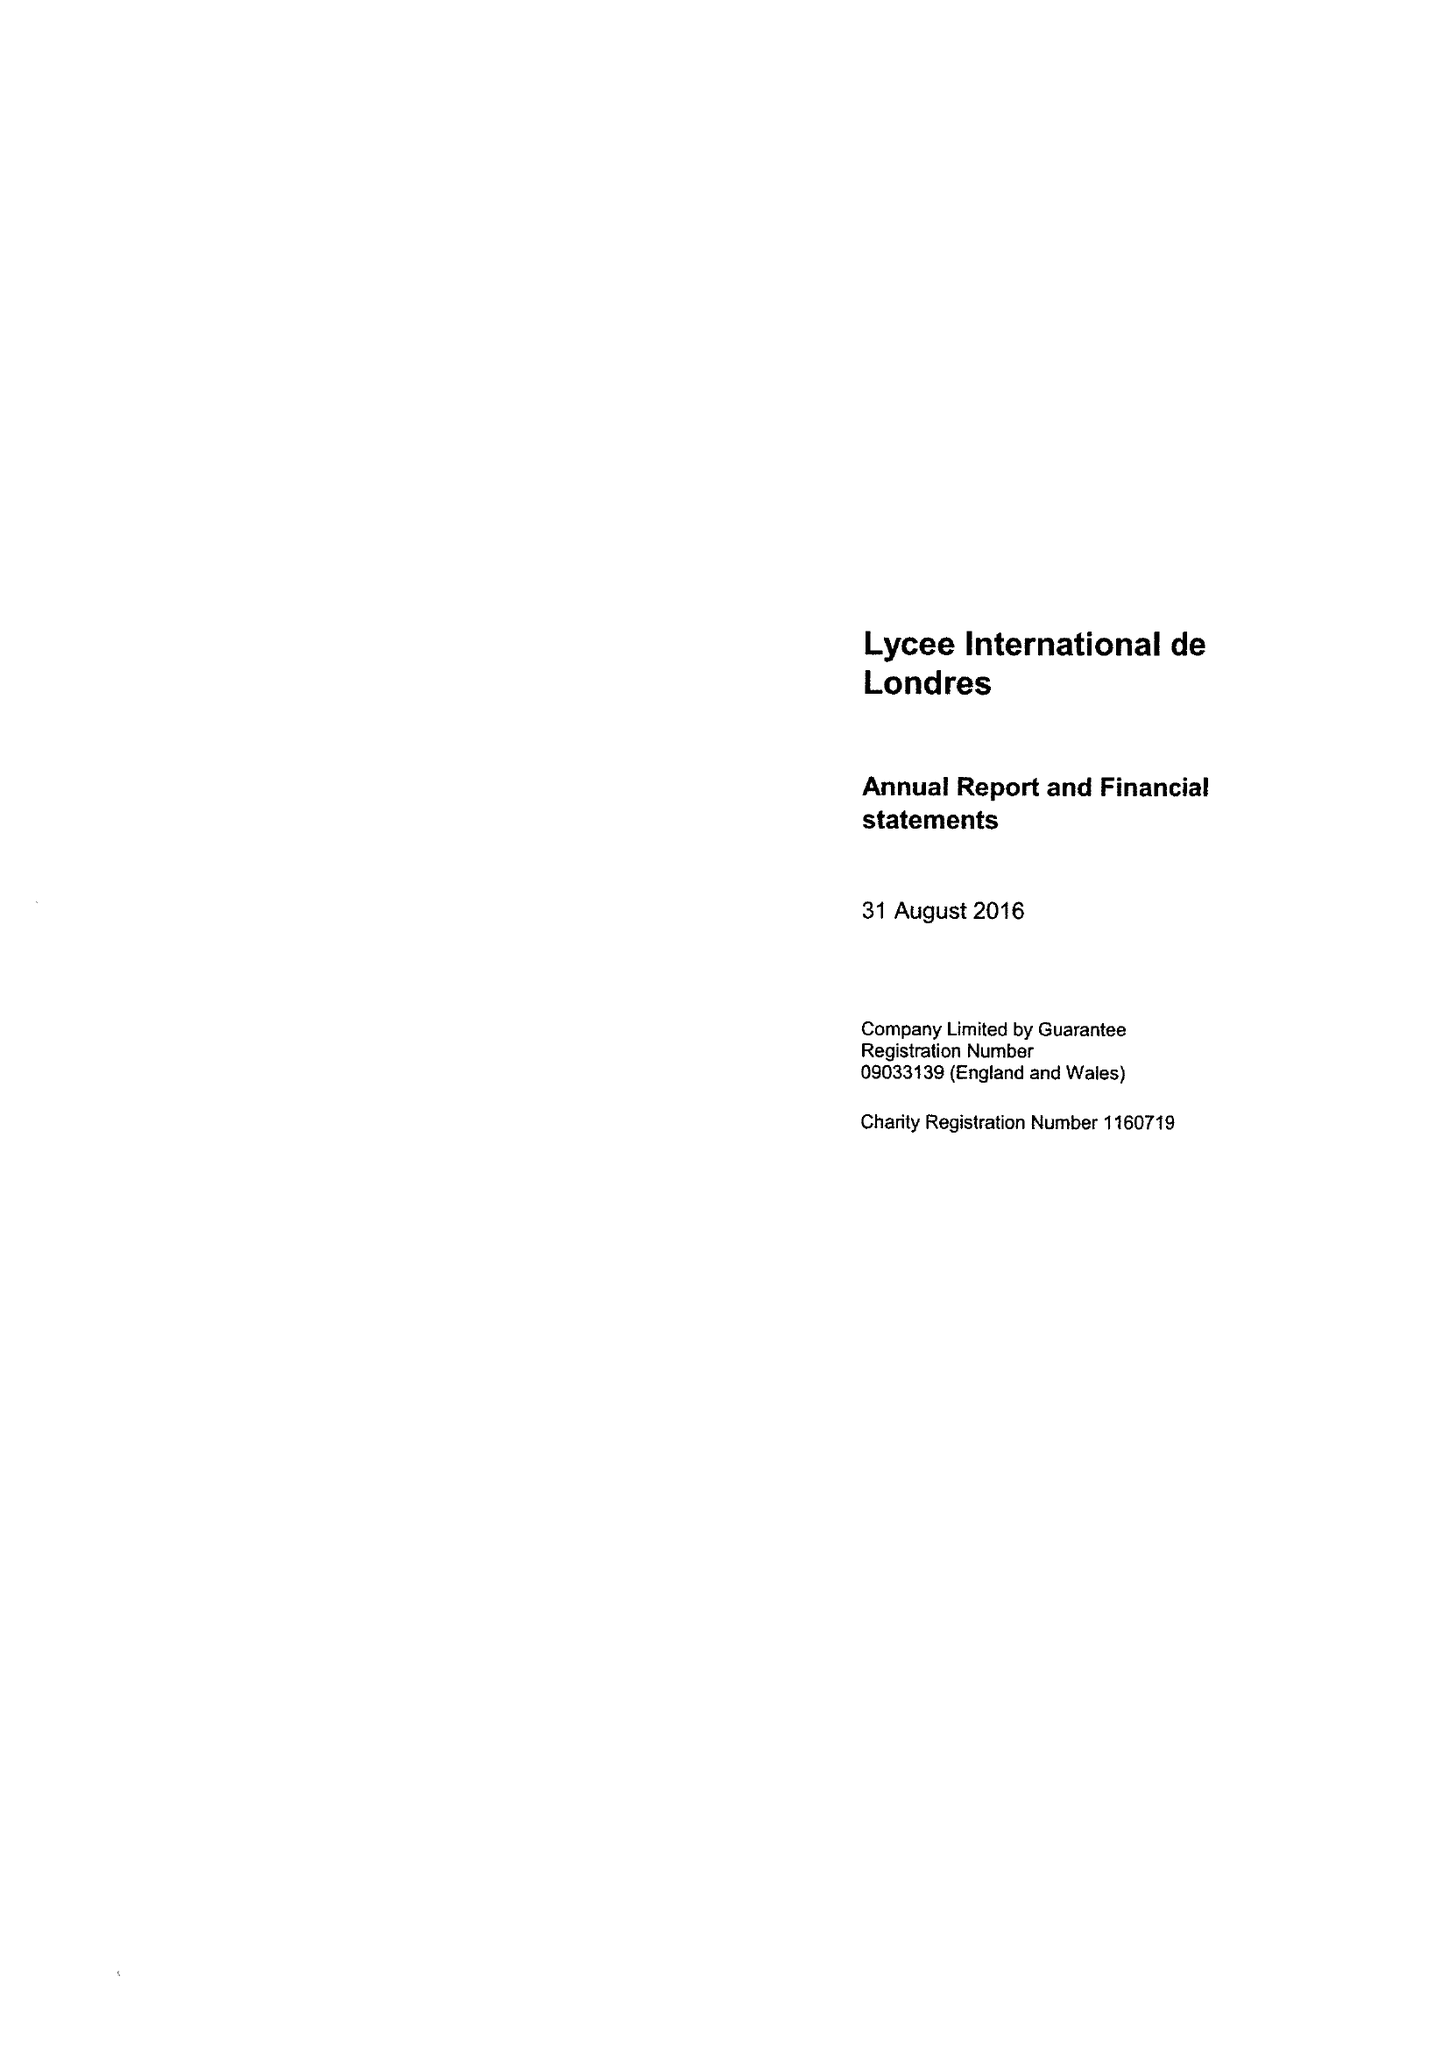What is the value for the address__street_line?
Answer the question using a single word or phrase. 54 FORTY LANE 